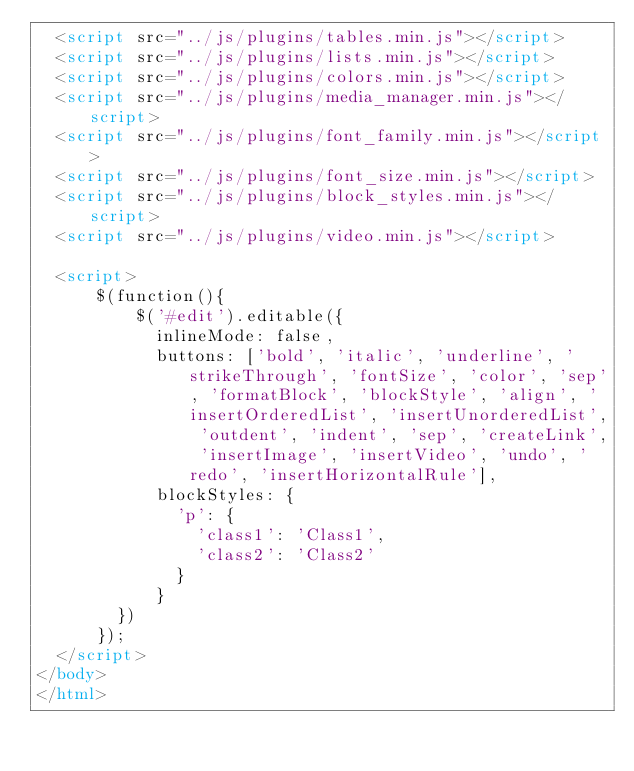Convert code to text. <code><loc_0><loc_0><loc_500><loc_500><_HTML_>  <script src="../js/plugins/tables.min.js"></script>
  <script src="../js/plugins/lists.min.js"></script>
  <script src="../js/plugins/colors.min.js"></script>
  <script src="../js/plugins/media_manager.min.js"></script>
  <script src="../js/plugins/font_family.min.js"></script>
  <script src="../js/plugins/font_size.min.js"></script>
  <script src="../js/plugins/block_styles.min.js"></script>
  <script src="../js/plugins/video.min.js"></script>

  <script>
      $(function(){
          $('#edit').editable({
            inlineMode: false,
            buttons: ['bold', 'italic', 'underline', 'strikeThrough', 'fontSize', 'color', 'sep', 'formatBlock', 'blockStyle', 'align', 'insertOrderedList', 'insertUnorderedList', 'outdent', 'indent', 'sep', 'createLink', 'insertImage', 'insertVideo', 'undo', 'redo', 'insertHorizontalRule'],
            blockStyles: {
              'p': {
                'class1': 'Class1',
                'class2': 'Class2'
              }
            }
        })
      });
  </script>
</body>
</html>
</code> 